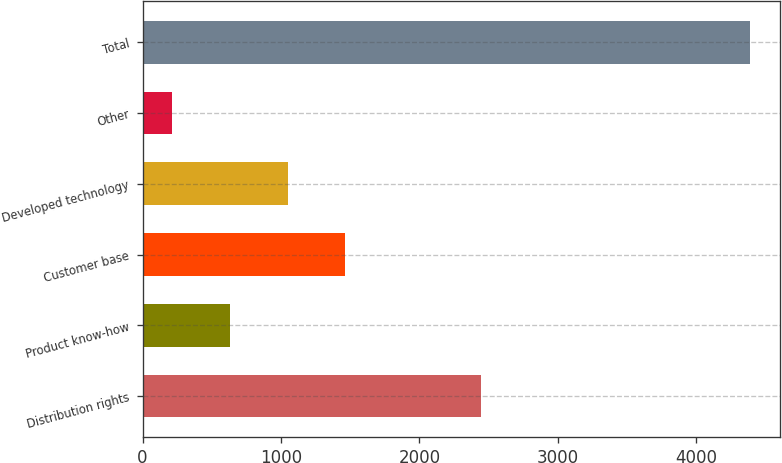<chart> <loc_0><loc_0><loc_500><loc_500><bar_chart><fcel>Distribution rights<fcel>Product know-how<fcel>Customer base<fcel>Developed technology<fcel>Other<fcel>Total<nl><fcel>2445<fcel>630.3<fcel>1464.9<fcel>1047.6<fcel>213<fcel>4386<nl></chart> 